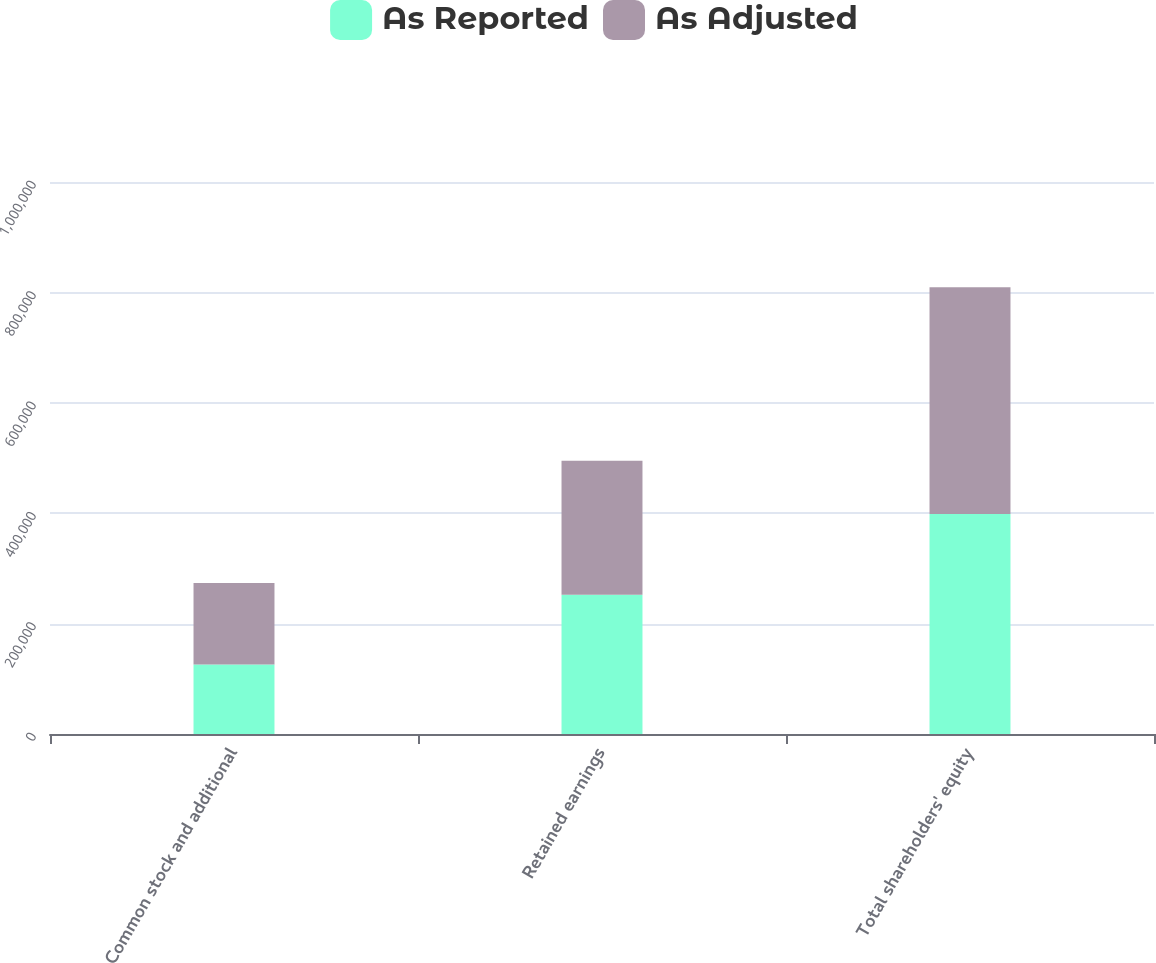Convert chart. <chart><loc_0><loc_0><loc_500><loc_500><stacked_bar_chart><ecel><fcel>Common stock and additional<fcel>Retained earnings<fcel>Total shareholders' equity<nl><fcel>As Reported<fcel>126090<fcel>252322<fcel>398752<nl><fcel>As Adjusted<fcel>147395<fcel>242618<fcel>410352<nl></chart> 